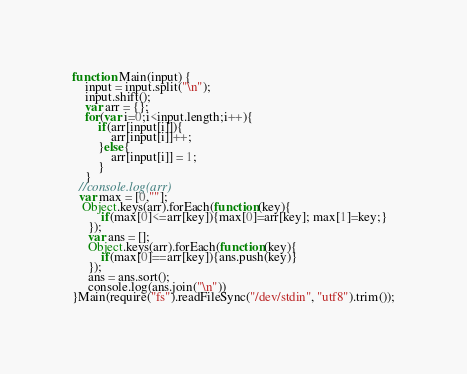<code> <loc_0><loc_0><loc_500><loc_500><_JavaScript_>function Main(input) {
	input = input.split("\n");
	input.shift();
	var arr = {};
	for(var i=0;i<input.length;i++){
		if(arr[input[i]]){
			arr[input[i]]++;
		}else{
			arr[input[i]] = 1;
		}
	}
  //console.log(arr)
  var max = [0,""];
   Object.keys(arr).forEach(function(key){
		 if(max[0]<=arr[key]){max[0]=arr[key]; max[1]=key;}
	 });
	 var ans = [];
	 Object.keys(arr).forEach(function(key){
		 if(max[0]==arr[key]){ans.push(key)}
	 });
	 ans = ans.sort();
	 console.log(ans.join("\n"))
}Main(require("fs").readFileSync("/dev/stdin", "utf8").trim());
</code> 